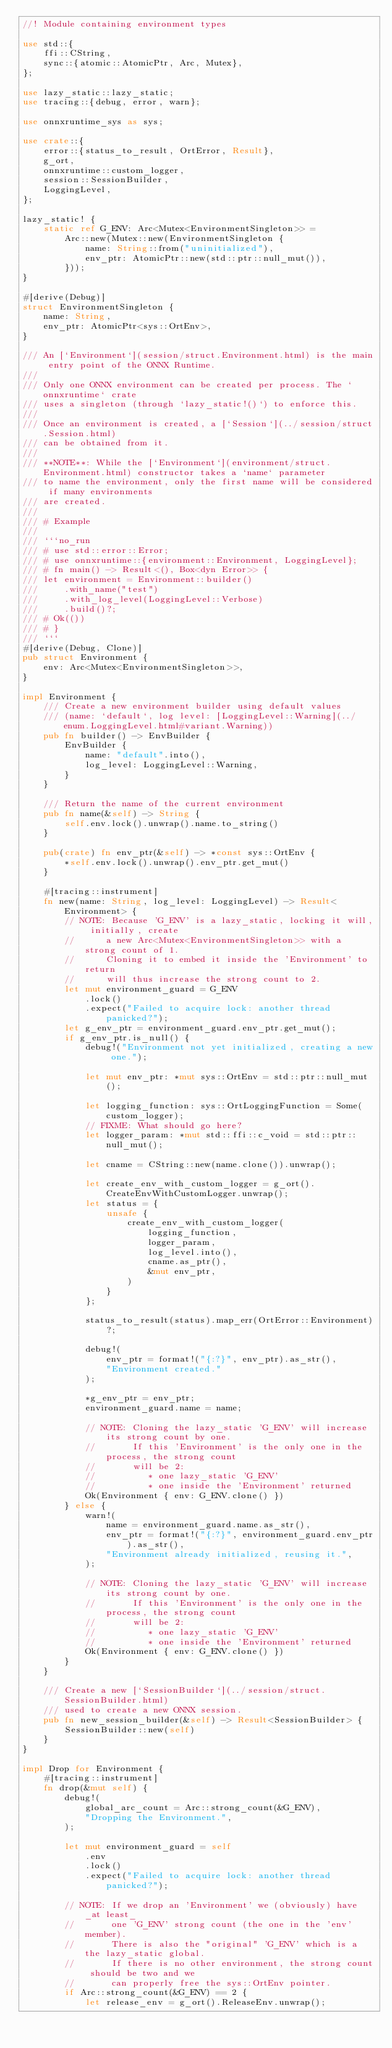<code> <loc_0><loc_0><loc_500><loc_500><_Rust_>//! Module containing environment types

use std::{
    ffi::CString,
    sync::{atomic::AtomicPtr, Arc, Mutex},
};

use lazy_static::lazy_static;
use tracing::{debug, error, warn};

use onnxruntime_sys as sys;

use crate::{
    error::{status_to_result, OrtError, Result},
    g_ort,
    onnxruntime::custom_logger,
    session::SessionBuilder,
    LoggingLevel,
};

lazy_static! {
    static ref G_ENV: Arc<Mutex<EnvironmentSingleton>> =
        Arc::new(Mutex::new(EnvironmentSingleton {
            name: String::from("uninitialized"),
            env_ptr: AtomicPtr::new(std::ptr::null_mut()),
        }));
}

#[derive(Debug)]
struct EnvironmentSingleton {
    name: String,
    env_ptr: AtomicPtr<sys::OrtEnv>,
}

/// An [`Environment`](session/struct.Environment.html) is the main entry point of the ONNX Runtime.
///
/// Only one ONNX environment can be created per process. The `onnxruntime` crate
/// uses a singleton (through `lazy_static!()`) to enforce this.
///
/// Once an environment is created, a [`Session`](../session/struct.Session.html)
/// can be obtained from it.
///
/// **NOTE**: While the [`Environment`](environment/struct.Environment.html) constructor takes a `name` parameter
/// to name the environment, only the first name will be considered if many environments
/// are created.
///
/// # Example
///
/// ```no_run
/// # use std::error::Error;
/// # use onnxruntime::{environment::Environment, LoggingLevel};
/// # fn main() -> Result<(), Box<dyn Error>> {
/// let environment = Environment::builder()
///     .with_name("test")
///     .with_log_level(LoggingLevel::Verbose)
///     .build()?;
/// # Ok(())
/// # }
/// ```
#[derive(Debug, Clone)]
pub struct Environment {
    env: Arc<Mutex<EnvironmentSingleton>>,
}

impl Environment {
    /// Create a new environment builder using default values
    /// (name: `default`, log level: [LoggingLevel::Warning](../enum.LoggingLevel.html#variant.Warning))
    pub fn builder() -> EnvBuilder {
        EnvBuilder {
            name: "default".into(),
            log_level: LoggingLevel::Warning,
        }
    }

    /// Return the name of the current environment
    pub fn name(&self) -> String {
        self.env.lock().unwrap().name.to_string()
    }

    pub(crate) fn env_ptr(&self) -> *const sys::OrtEnv {
        *self.env.lock().unwrap().env_ptr.get_mut()
    }

    #[tracing::instrument]
    fn new(name: String, log_level: LoggingLevel) -> Result<Environment> {
        // NOTE: Because 'G_ENV' is a lazy_static, locking it will, initially, create
        //      a new Arc<Mutex<EnvironmentSingleton>> with a strong count of 1.
        //      Cloning it to embed it inside the 'Environment' to return
        //      will thus increase the strong count to 2.
        let mut environment_guard = G_ENV
            .lock()
            .expect("Failed to acquire lock: another thread panicked?");
        let g_env_ptr = environment_guard.env_ptr.get_mut();
        if g_env_ptr.is_null() {
            debug!("Environment not yet initialized, creating a new one.");

            let mut env_ptr: *mut sys::OrtEnv = std::ptr::null_mut();

            let logging_function: sys::OrtLoggingFunction = Some(custom_logger);
            // FIXME: What should go here?
            let logger_param: *mut std::ffi::c_void = std::ptr::null_mut();

            let cname = CString::new(name.clone()).unwrap();

            let create_env_with_custom_logger = g_ort().CreateEnvWithCustomLogger.unwrap();
            let status = {
                unsafe {
                    create_env_with_custom_logger(
                        logging_function,
                        logger_param,
                        log_level.into(),
                        cname.as_ptr(),
                        &mut env_ptr,
                    )
                }
            };

            status_to_result(status).map_err(OrtError::Environment)?;

            debug!(
                env_ptr = format!("{:?}", env_ptr).as_str(),
                "Environment created."
            );

            *g_env_ptr = env_ptr;
            environment_guard.name = name;

            // NOTE: Cloning the lazy_static 'G_ENV' will increase its strong count by one.
            //       If this 'Environment' is the only one in the process, the strong count
            //       will be 2:
            //          * one lazy_static 'G_ENV'
            //          * one inside the 'Environment' returned
            Ok(Environment { env: G_ENV.clone() })
        } else {
            warn!(
                name = environment_guard.name.as_str(),
                env_ptr = format!("{:?}", environment_guard.env_ptr).as_str(),
                "Environment already initialized, reusing it.",
            );

            // NOTE: Cloning the lazy_static 'G_ENV' will increase its strong count by one.
            //       If this 'Environment' is the only one in the process, the strong count
            //       will be 2:
            //          * one lazy_static 'G_ENV'
            //          * one inside the 'Environment' returned
            Ok(Environment { env: G_ENV.clone() })
        }
    }

    /// Create a new [`SessionBuilder`](../session/struct.SessionBuilder.html)
    /// used to create a new ONNX session.
    pub fn new_session_builder(&self) -> Result<SessionBuilder> {
        SessionBuilder::new(self)
    }
}

impl Drop for Environment {
    #[tracing::instrument]
    fn drop(&mut self) {
        debug!(
            global_arc_count = Arc::strong_count(&G_ENV),
            "Dropping the Environment.",
        );

        let mut environment_guard = self
            .env
            .lock()
            .expect("Failed to acquire lock: another thread panicked?");

        // NOTE: If we drop an 'Environment' we (obviously) have _at least_
        //       one 'G_ENV' strong count (the one in the 'env' member).
        //       There is also the "original" 'G_ENV' which is a the lazy_static global.
        //       If there is no other environment, the strong count should be two and we
        //       can properly free the sys::OrtEnv pointer.
        if Arc::strong_count(&G_ENV) == 2 {
            let release_env = g_ort().ReleaseEnv.unwrap();</code> 